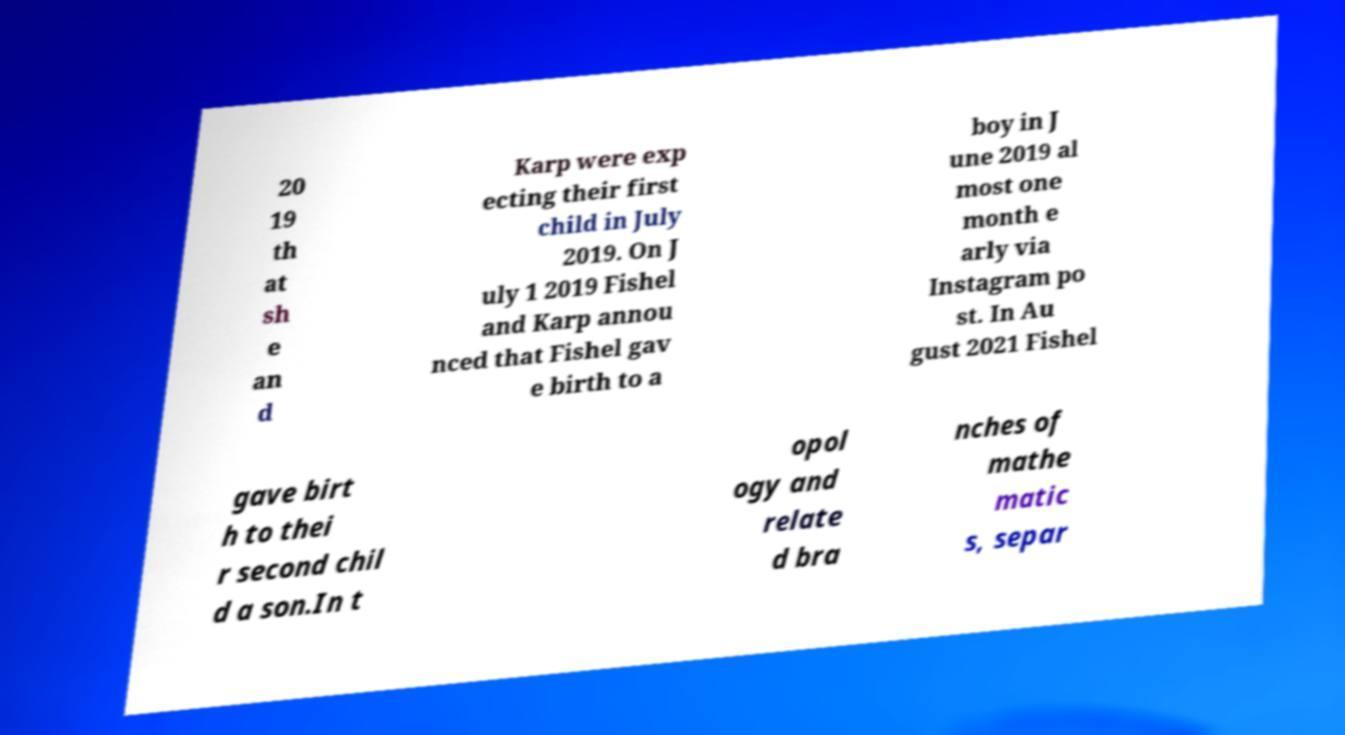Please read and relay the text visible in this image. What does it say? 20 19 th at sh e an d Karp were exp ecting their first child in July 2019. On J uly 1 2019 Fishel and Karp annou nced that Fishel gav e birth to a boy in J une 2019 al most one month e arly via Instagram po st. In Au gust 2021 Fishel gave birt h to thei r second chil d a son.In t opol ogy and relate d bra nches of mathe matic s, separ 